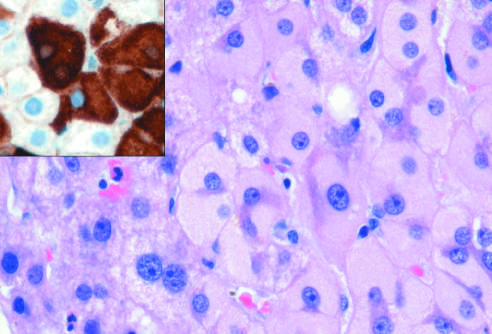does the schematic diagram of intimal thickening show the presence of abundant, finely granular pink cytoplasmic inclusions?
Answer the question using a single word or phrase. No 